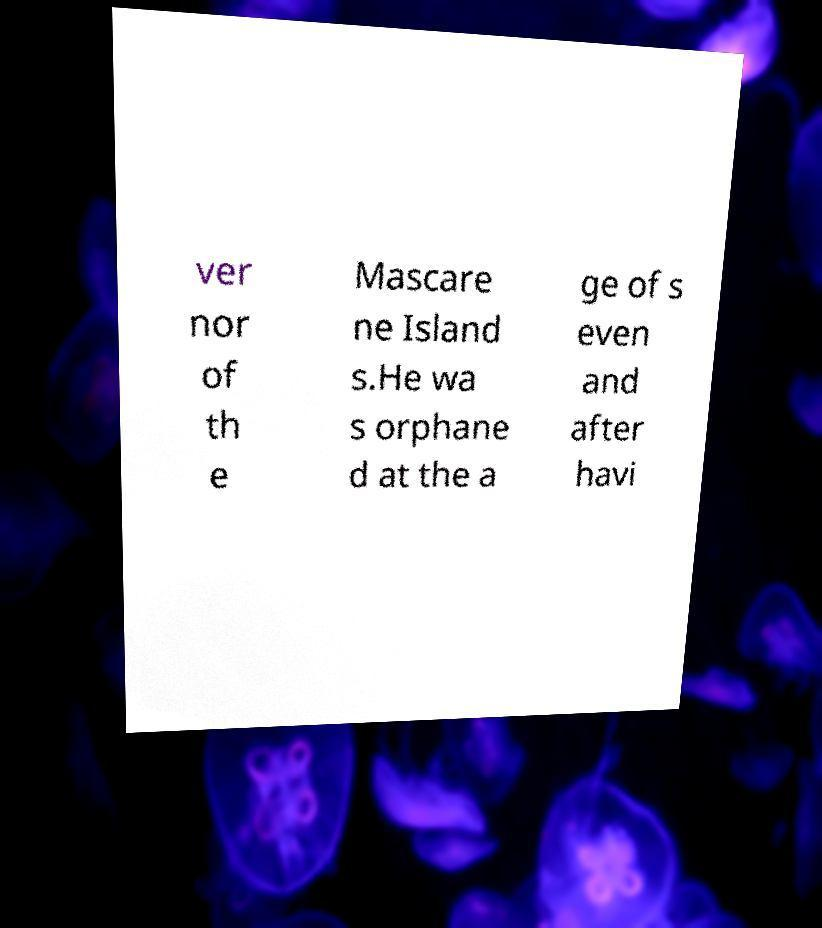Please read and relay the text visible in this image. What does it say? ver nor of th e Mascare ne Island s.He wa s orphane d at the a ge of s even and after havi 